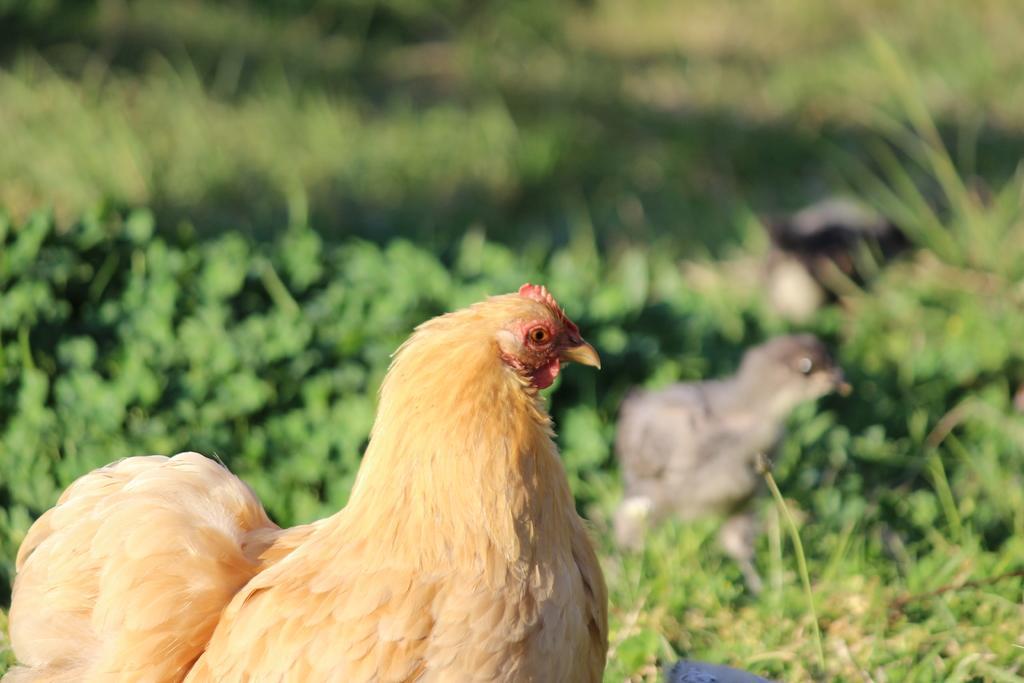Can you describe this image briefly? This image is taken outdoors. At the bottom of the image there is a ground and there are a few plants. On the left side of the image there is a hen and there is a bird on the ground. 